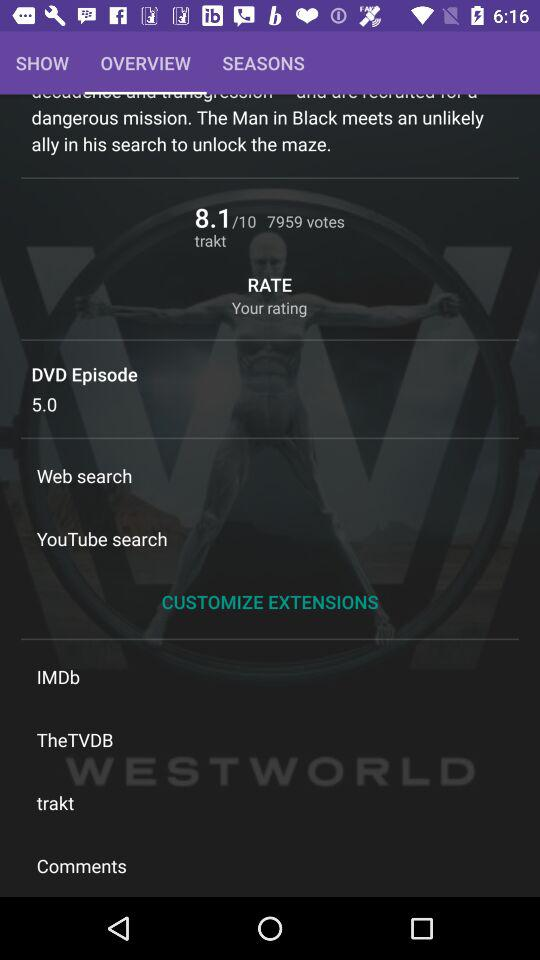How many votes are there? There are 7959 votes. 